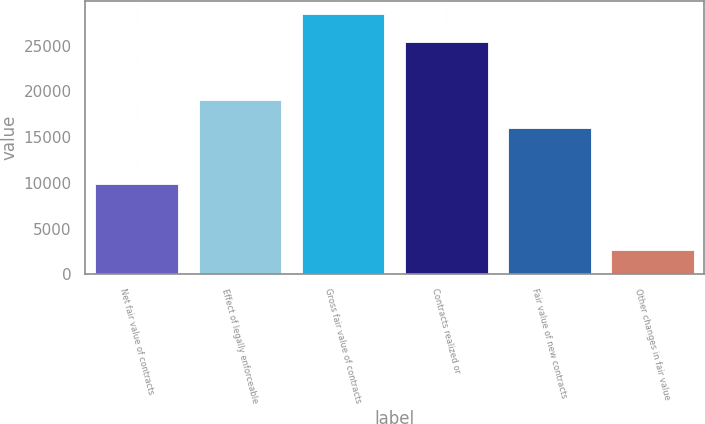Convert chart to OTSL. <chart><loc_0><loc_0><loc_500><loc_500><bar_chart><fcel>Net fair value of contracts<fcel>Effect of legally enforceable<fcel>Gross fair value of contracts<fcel>Contracts realized or<fcel>Fair value of new contracts<fcel>Other changes in fair value<nl><fcel>9929<fcel>19076<fcel>28490<fcel>25441<fcel>16027<fcel>2647<nl></chart> 